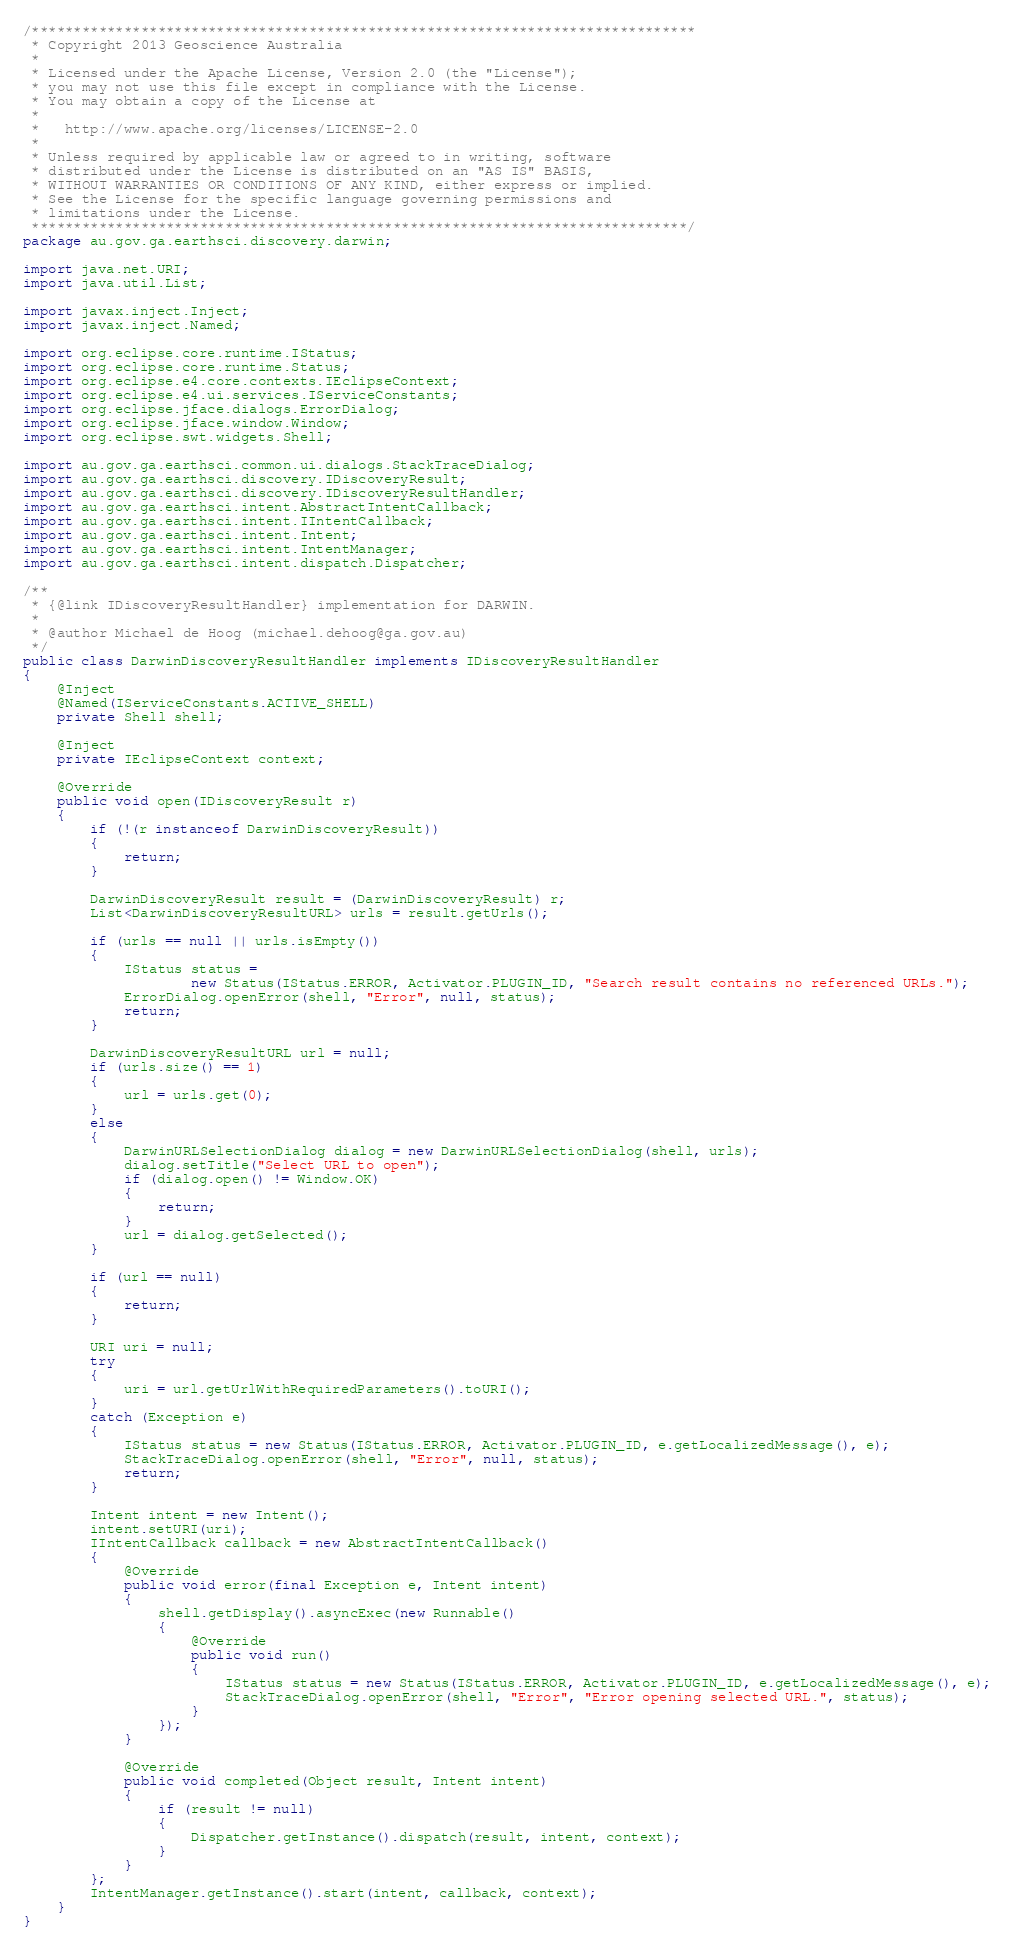Convert code to text. <code><loc_0><loc_0><loc_500><loc_500><_Java_>/*******************************************************************************
 * Copyright 2013 Geoscience Australia
 * 
 * Licensed under the Apache License, Version 2.0 (the "License");
 * you may not use this file except in compliance with the License.
 * You may obtain a copy of the License at
 * 
 *   http://www.apache.org/licenses/LICENSE-2.0
 * 
 * Unless required by applicable law or agreed to in writing, software
 * distributed under the License is distributed on an "AS IS" BASIS,
 * WITHOUT WARRANTIES OR CONDITIONS OF ANY KIND, either express or implied.
 * See the License for the specific language governing permissions and
 * limitations under the License.
 ******************************************************************************/
package au.gov.ga.earthsci.discovery.darwin;

import java.net.URI;
import java.util.List;

import javax.inject.Inject;
import javax.inject.Named;

import org.eclipse.core.runtime.IStatus;
import org.eclipse.core.runtime.Status;
import org.eclipse.e4.core.contexts.IEclipseContext;
import org.eclipse.e4.ui.services.IServiceConstants;
import org.eclipse.jface.dialogs.ErrorDialog;
import org.eclipse.jface.window.Window;
import org.eclipse.swt.widgets.Shell;

import au.gov.ga.earthsci.common.ui.dialogs.StackTraceDialog;
import au.gov.ga.earthsci.discovery.IDiscoveryResult;
import au.gov.ga.earthsci.discovery.IDiscoveryResultHandler;
import au.gov.ga.earthsci.intent.AbstractIntentCallback;
import au.gov.ga.earthsci.intent.IIntentCallback;
import au.gov.ga.earthsci.intent.Intent;
import au.gov.ga.earthsci.intent.IntentManager;
import au.gov.ga.earthsci.intent.dispatch.Dispatcher;

/**
 * {@link IDiscoveryResultHandler} implementation for DARWIN.
 * 
 * @author Michael de Hoog (michael.dehoog@ga.gov.au)
 */
public class DarwinDiscoveryResultHandler implements IDiscoveryResultHandler
{
	@Inject
	@Named(IServiceConstants.ACTIVE_SHELL)
	private Shell shell;

	@Inject
	private IEclipseContext context;

	@Override
	public void open(IDiscoveryResult r)
	{
		if (!(r instanceof DarwinDiscoveryResult))
		{
			return;
		}

		DarwinDiscoveryResult result = (DarwinDiscoveryResult) r;
		List<DarwinDiscoveryResultURL> urls = result.getUrls();

		if (urls == null || urls.isEmpty())
		{
			IStatus status =
					new Status(IStatus.ERROR, Activator.PLUGIN_ID, "Search result contains no referenced URLs.");
			ErrorDialog.openError(shell, "Error", null, status);
			return;
		}

		DarwinDiscoveryResultURL url = null;
		if (urls.size() == 1)
		{
			url = urls.get(0);
		}
		else
		{
			DarwinURLSelectionDialog dialog = new DarwinURLSelectionDialog(shell, urls);
			dialog.setTitle("Select URL to open");
			if (dialog.open() != Window.OK)
			{
				return;
			}
			url = dialog.getSelected();
		}

		if (url == null)
		{
			return;
		}

		URI uri = null;
		try
		{
			uri = url.getUrlWithRequiredParameters().toURI();
		}
		catch (Exception e)
		{
			IStatus status = new Status(IStatus.ERROR, Activator.PLUGIN_ID, e.getLocalizedMessage(), e);
			StackTraceDialog.openError(shell, "Error", null, status);
			return;
		}

		Intent intent = new Intent();
		intent.setURI(uri);
		IIntentCallback callback = new AbstractIntentCallback()
		{
			@Override
			public void error(final Exception e, Intent intent)
			{
				shell.getDisplay().asyncExec(new Runnable()
				{
					@Override
					public void run()
					{
						IStatus status = new Status(IStatus.ERROR, Activator.PLUGIN_ID, e.getLocalizedMessage(), e);
						StackTraceDialog.openError(shell, "Error", "Error opening selected URL.", status);
					}
				});
			}

			@Override
			public void completed(Object result, Intent intent)
			{
				if (result != null)
				{
					Dispatcher.getInstance().dispatch(result, intent, context);
				}
			}
		};
		IntentManager.getInstance().start(intent, callback, context);
	}
}
</code> 